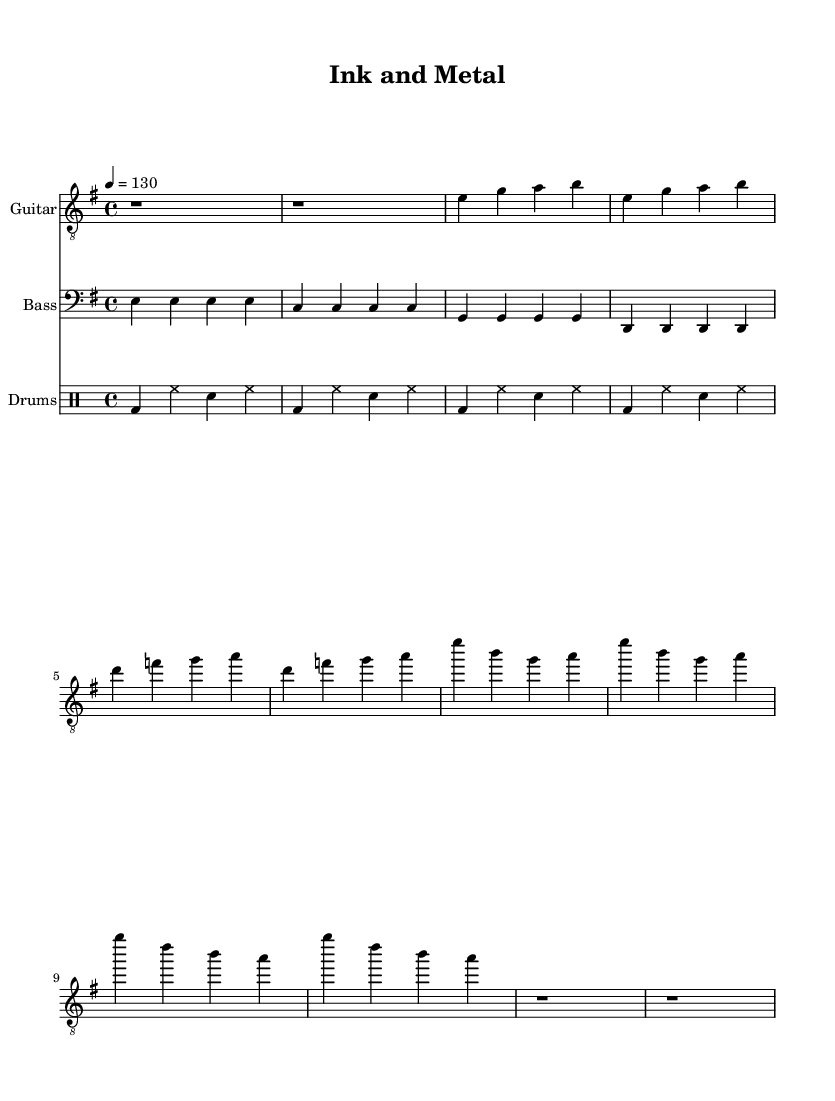What is the key signature of this music? The key signature is indicated at the beginning of the score and shows one sharp, indicating E minor, which is the relative minor of G major.
Answer: E minor What is the time signature of the composition? The time signature is located at the beginning of the sheet music, showing a 4 over 4, which means there are four beats in each measure and the quarter note gets one beat.
Answer: 4/4 What is the tempo marking for this piece? The tempo is specified as a number indicating beats per minute (BPM) at the start of the score, which is 130 beats per minute, meaning the piece is played at a moderate pace.
Answer: 130 How many measures are in the chorus section? The chorus consists of four measures, and this can be determined by counting the number of distinct groups present in the written music. Each group divided by a vertical line represents a measure.
Answer: 4 What instruments are featured in this piece? The instruments are listed at the beginning of their respective staves, showing three types: Guitar, Bass, and Drums. Each is indicated with a different staff appropriate for the instrument's clef.
Answer: Guitar, Bass, Drums How many verses are present in the song? The number of verses is indicated by the lyrics written beneath the music. In this case, there is a single verse followed by the chorus. Therefore, we only consider the distinct section before the chorus as a 'verse.'
Answer: 1 What style of music does this sheet represent? This music is characterized by its heavy guitar riffs, powerful bass lines, and energetic drumming typical of the hard rock genre, which celebrates themes of craftsmanship and creativity in printing and typesetting.
Answer: Hard rock 